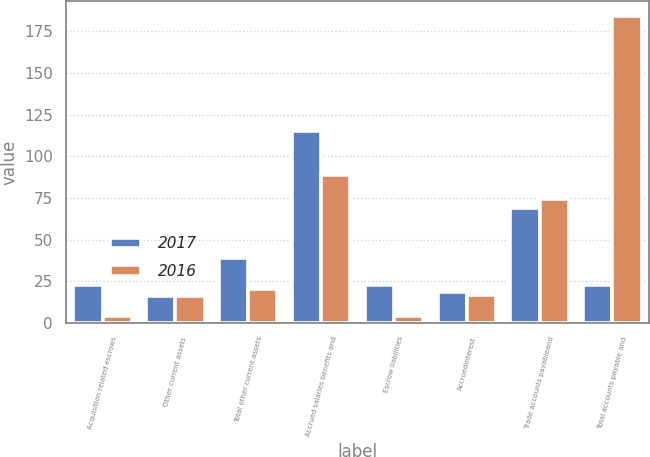Convert chart to OTSL. <chart><loc_0><loc_0><loc_500><loc_500><stacked_bar_chart><ecel><fcel>Acquisition related escrows<fcel>Other current assets<fcel>Total other current assets<fcel>Accrued salaries benefits and<fcel>Escrow liabilities<fcel>Accruedinterest<fcel>Trade accounts payableand<fcel>Total accounts payable and<nl><fcel>2017<fcel>22.9<fcel>16.2<fcel>39.1<fcel>115.3<fcel>22.9<fcel>18.3<fcel>68.9<fcel>22.9<nl><fcel>2016<fcel>4.1<fcel>16.2<fcel>20.3<fcel>88.6<fcel>4.1<fcel>17<fcel>74.3<fcel>184<nl></chart> 